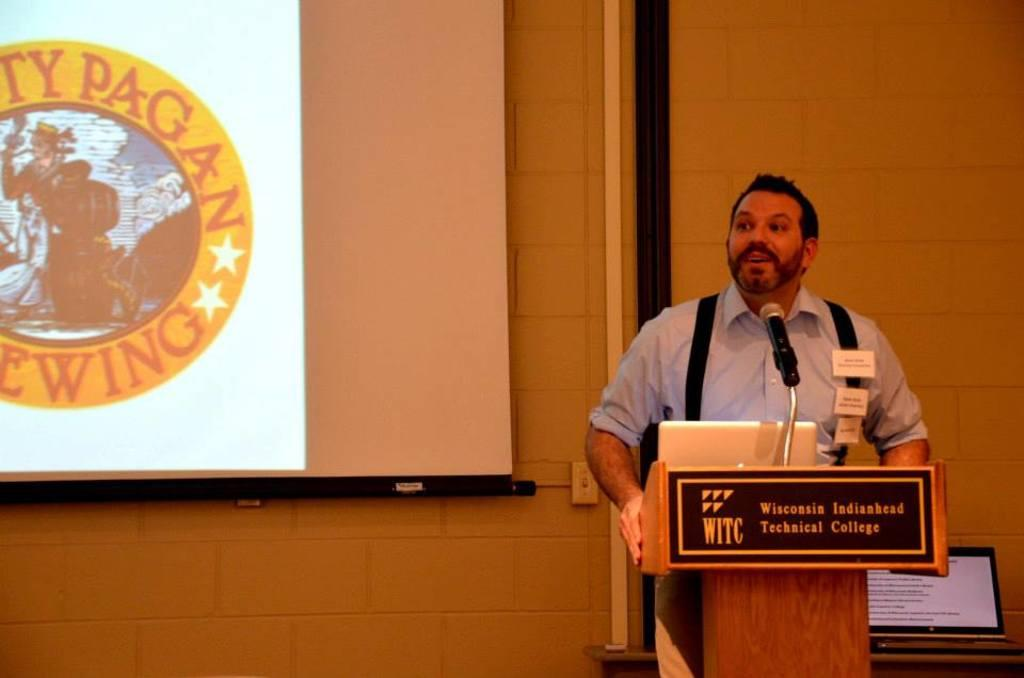Who is present in the image? There is a person standing on the right side of the image. What is the person doing in the image? The person is at a lectern. What is on the lectern? The lectern has a mic and a laptop. What can be seen in the background of the image? There is a screen and a wall in the background of the image. Are there any other laptops visible in the image? Yes, there is another laptop in the background of the image. What type of pie is being served at the event in the image? There is no pie or event present in the image; it features a person at a lectern with a mic and a laptop. What type of pleasure can be seen on the person's face in the image? There is no indication of the person's emotions or pleasure in the image, as their facial expression is not visible. 